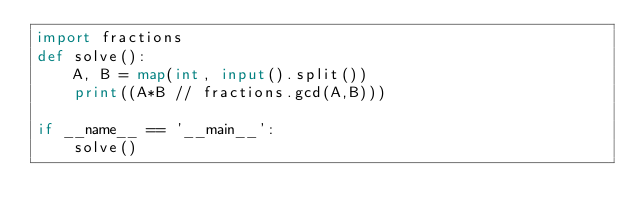<code> <loc_0><loc_0><loc_500><loc_500><_Python_>import fractions
def solve():
    A, B = map(int, input().split())
    print((A*B // fractions.gcd(A,B)))

if __name__ == '__main__':
    solve()</code> 